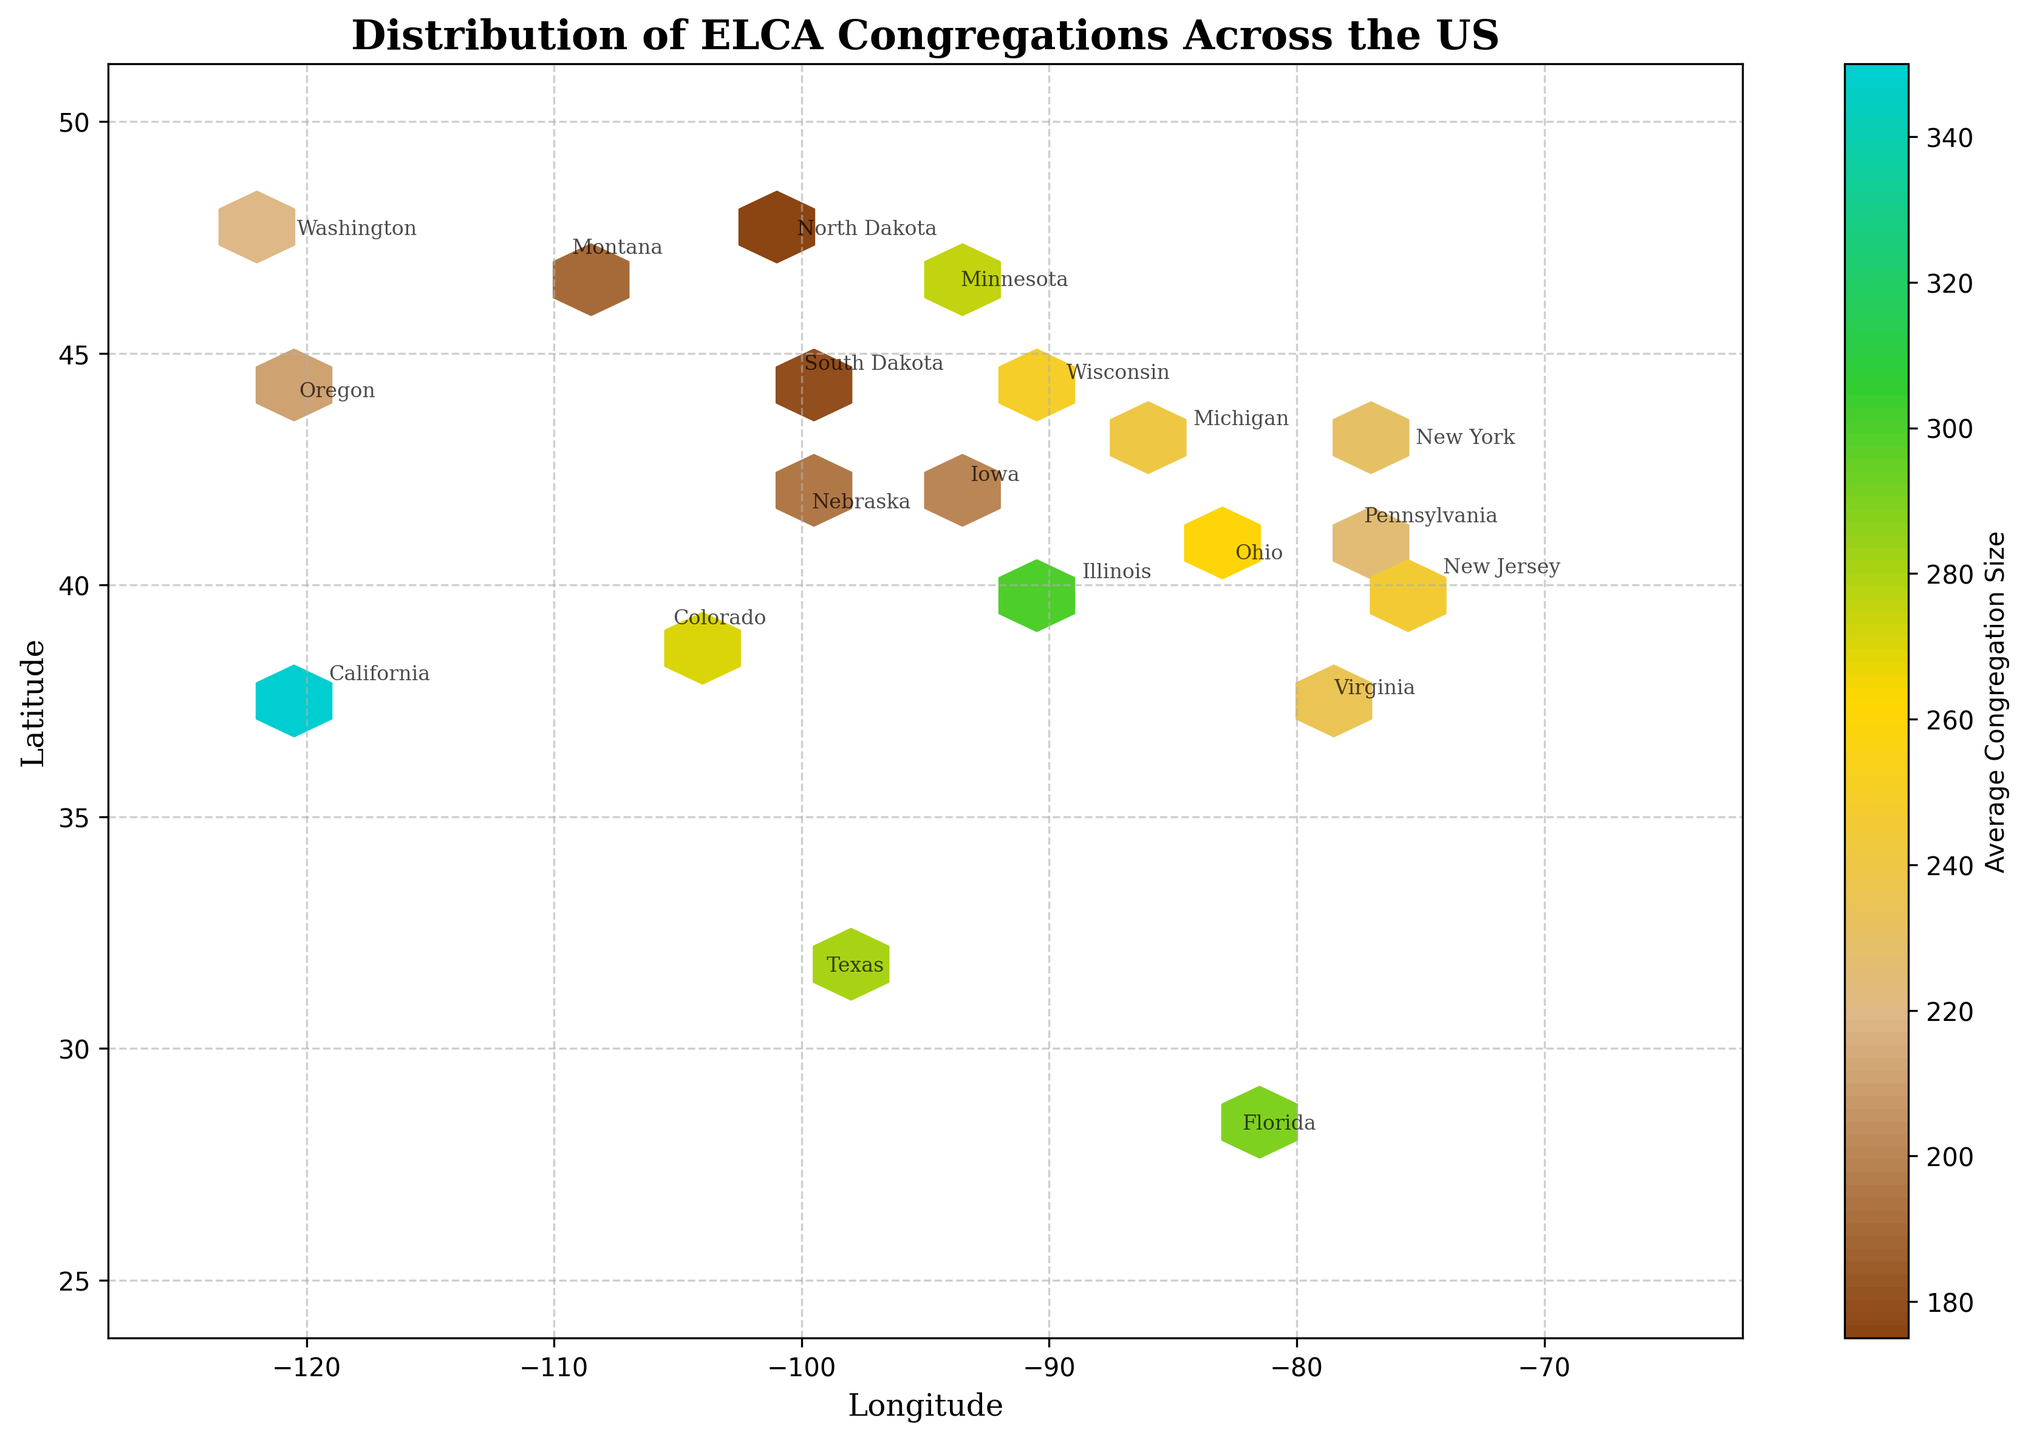What is the title of the plot? The title of the plot is displayed prominently at the top of the figure and reads "Distribution of ELCA Congregations Across the US."
Answer: Distribution of ELCA Congregations Across the US Which region (longitude and latitude bounds) has been used for the hexbin plot? The extent parameter has been set to cover the area from longitude -125 to -65 and latitude 25 to 50, encapsulating the continental US on the plot.
Answer: Longitude: -125 to -65, Latitude: 25 to 50 Which states have the highest average congregation size and where are they located on the map? California has the highest average congregation size and is located in the western part of the US, specifically in the region marked at longitude -119.4 and latitude 37.8.
Answer: California In which state are ELCA congregations the most densely located on the map, and what color indicates this density? Minnesota has the highest congregation count making it the densest state, represented by darker shades on the hexbin plot.
Answer: Minnesota Compare the density of congregations and average sizes between Minnesota and Iowa. Minnesota has a higher congregation density and its average congregation size is larger than Iowa. This can be seen through the darker, more concentrated hexbins for Minnesota and its average size of 275 compared to Iowa's 200.
Answer: Minnesota has higher density and larger average size than Iowa What is the average congregation size shown in the color bar, and how is it represented on the plot? The color bar indicates average congregation size, with the range spanning from approximately 170 to 350. The size is represented by varying color intensities, with darker brown to teal colors denoting different sizes.
Answer: Approximately 170 to 350 Describe the trend of congregation density and average size as you move from the Midwest to the East Coast. The Midwest states such as Minnesota and Wisconsin have high congregation densities but as we move towards the East Coast, states like Pennsylvania and New York, the densities decrease, and average size decreases as well.
Answer: Density and size decrease moving East What are the longitude and latitude coordinates for Pennsylvania, and what do these hexbins represent? Pennsylvania is located around longitude -77.6 and latitude 41.2 on the map, with the hexbins representing moderate density and an average congregation size of around 225.
Answer: Longitude: -77.6, Latitude: 41.2 How does the average congregation size in Texas compare to that in Illinois? Texas has an average congregation size of 280, which is slightly smaller than Illinois's average size of 300. Despite Texas having fewer congregations, its average size is comparably large but still less than Illinois.
Answer: Texas: 280, Illinois: 300 